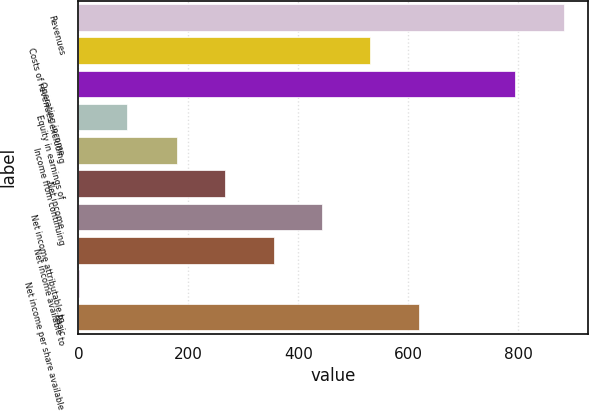<chart> <loc_0><loc_0><loc_500><loc_500><bar_chart><fcel>Revenues<fcel>Costs of revenues excluding<fcel>Operating income<fcel>Equity in earnings of<fcel>Income from continuing<fcel>Net income<fcel>Net income attributable to<fcel>Net income available to<fcel>Net income per share available<fcel>Basic<nl><fcel>883.48<fcel>531.24<fcel>795.42<fcel>88.49<fcel>179<fcel>267.06<fcel>443.18<fcel>355.12<fcel>0.43<fcel>619.3<nl></chart> 